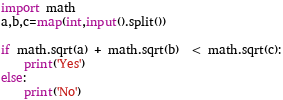Convert code to text. <code><loc_0><loc_0><loc_500><loc_500><_Python_>import math
a,b,c=map(int,input().split())

if math.sqrt(a) + math.sqrt(b)  < math.sqrt(c):
    print('Yes')
else:
    print('No')</code> 